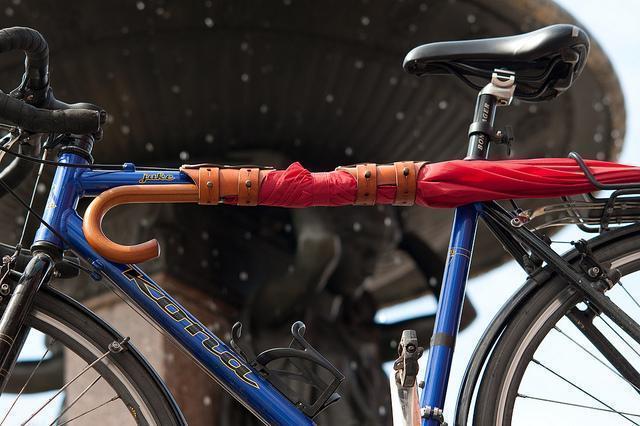What color is the umbrella strapped onto the bicycle frame's center bar?
Select the accurate response from the four choices given to answer the question.
Options: Yellow, green, red, blue. Red. 